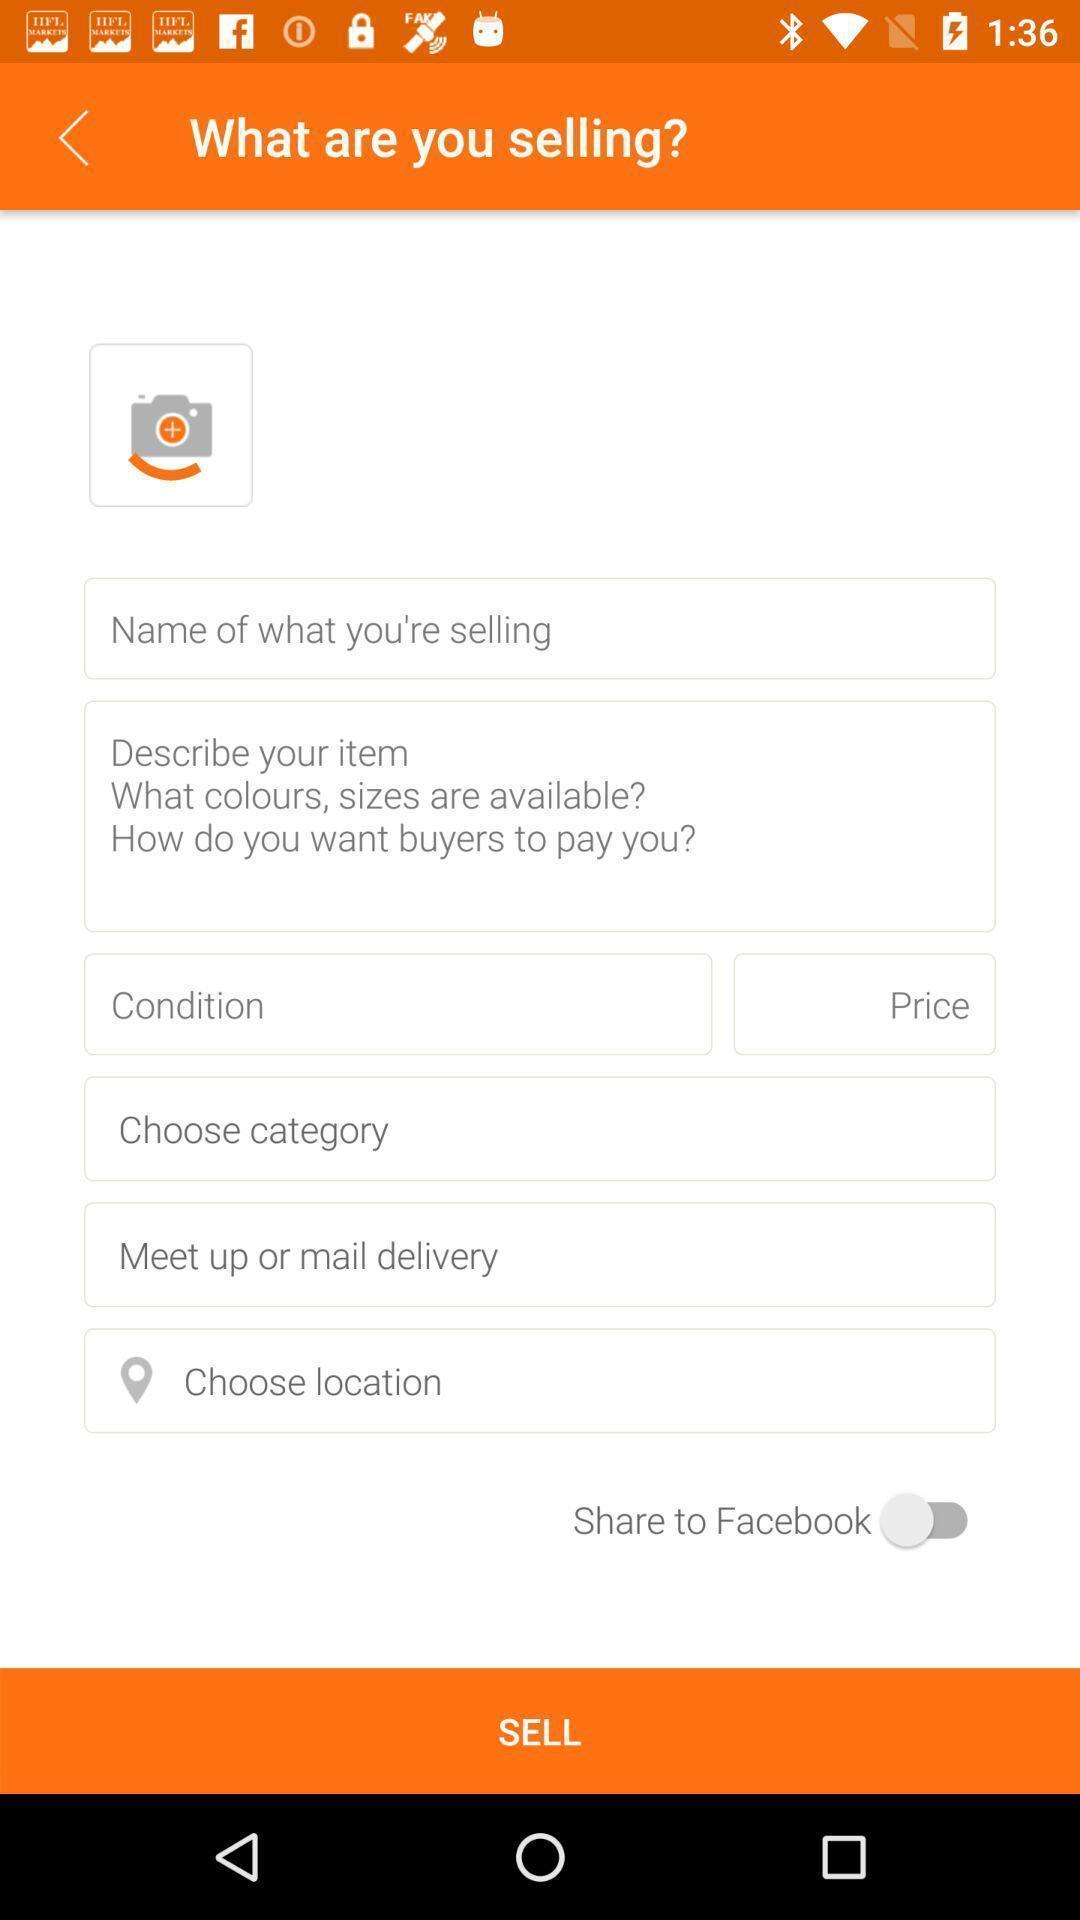Provide a textual representation of this image. Page showing about information selling. 